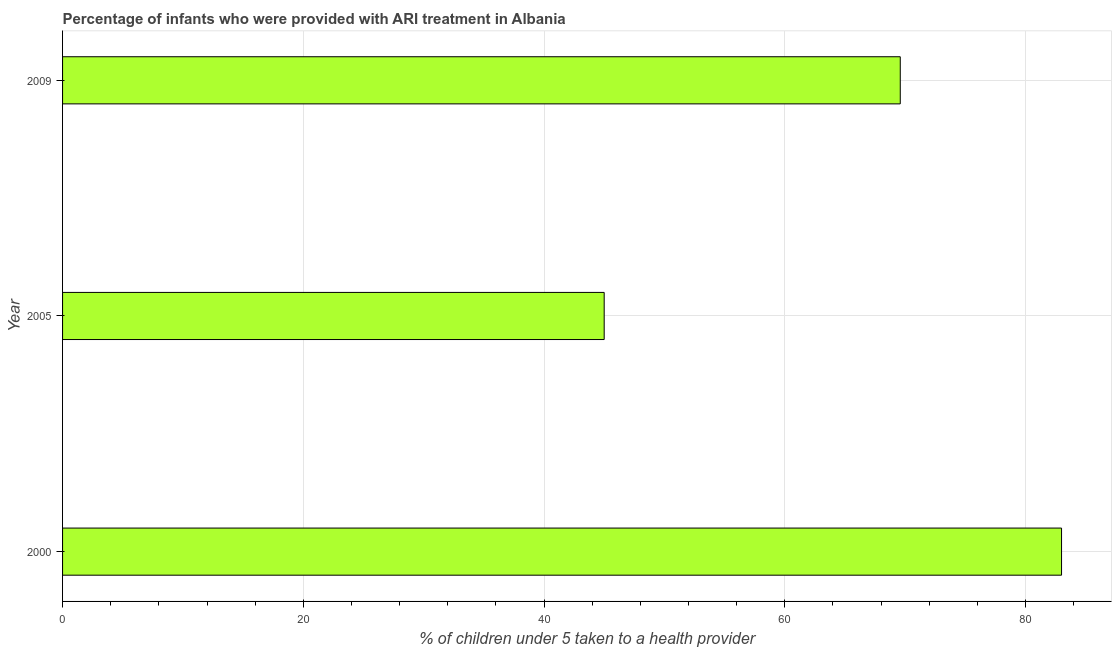Does the graph contain any zero values?
Ensure brevity in your answer.  No. What is the title of the graph?
Give a very brief answer. Percentage of infants who were provided with ARI treatment in Albania. What is the label or title of the X-axis?
Offer a very short reply. % of children under 5 taken to a health provider. What is the percentage of children who were provided with ari treatment in 2000?
Offer a very short reply. 83. Across all years, what is the maximum percentage of children who were provided with ari treatment?
Offer a terse response. 83. What is the sum of the percentage of children who were provided with ari treatment?
Your response must be concise. 197.6. What is the difference between the percentage of children who were provided with ari treatment in 2005 and 2009?
Keep it short and to the point. -24.6. What is the average percentage of children who were provided with ari treatment per year?
Your response must be concise. 65.87. What is the median percentage of children who were provided with ari treatment?
Give a very brief answer. 69.6. In how many years, is the percentage of children who were provided with ari treatment greater than 48 %?
Provide a succinct answer. 2. What is the ratio of the percentage of children who were provided with ari treatment in 2000 to that in 2009?
Provide a short and direct response. 1.19. Is the difference between the percentage of children who were provided with ari treatment in 2000 and 2005 greater than the difference between any two years?
Make the answer very short. Yes. What is the difference between the highest and the second highest percentage of children who were provided with ari treatment?
Your answer should be compact. 13.4. What is the difference between the highest and the lowest percentage of children who were provided with ari treatment?
Offer a terse response. 38. In how many years, is the percentage of children who were provided with ari treatment greater than the average percentage of children who were provided with ari treatment taken over all years?
Make the answer very short. 2. Are all the bars in the graph horizontal?
Your answer should be compact. Yes. Are the values on the major ticks of X-axis written in scientific E-notation?
Your answer should be very brief. No. What is the % of children under 5 taken to a health provider of 2009?
Offer a very short reply. 69.6. What is the difference between the % of children under 5 taken to a health provider in 2000 and 2005?
Your response must be concise. 38. What is the difference between the % of children under 5 taken to a health provider in 2000 and 2009?
Give a very brief answer. 13.4. What is the difference between the % of children under 5 taken to a health provider in 2005 and 2009?
Provide a succinct answer. -24.6. What is the ratio of the % of children under 5 taken to a health provider in 2000 to that in 2005?
Ensure brevity in your answer.  1.84. What is the ratio of the % of children under 5 taken to a health provider in 2000 to that in 2009?
Make the answer very short. 1.19. What is the ratio of the % of children under 5 taken to a health provider in 2005 to that in 2009?
Ensure brevity in your answer.  0.65. 